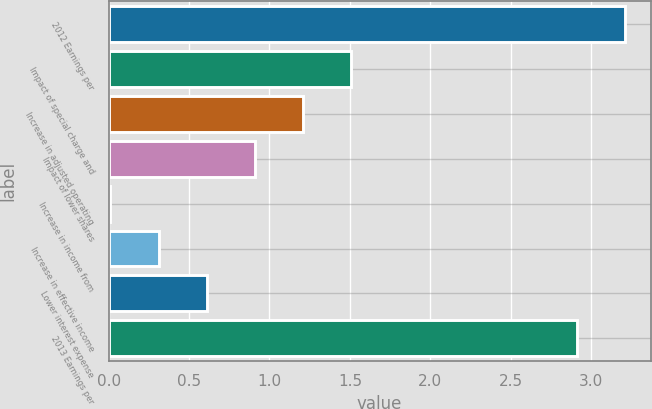Convert chart. <chart><loc_0><loc_0><loc_500><loc_500><bar_chart><fcel>2012 Earnings per<fcel>Impact of special charge and<fcel>Increase in adjusted operating<fcel>Impact of lower shares<fcel>Increase in income from<fcel>Increase in effective income<fcel>Lower interest expense<fcel>2013 Earnings per<nl><fcel>3.21<fcel>1.51<fcel>1.21<fcel>0.91<fcel>0.01<fcel>0.31<fcel>0.61<fcel>2.91<nl></chart> 